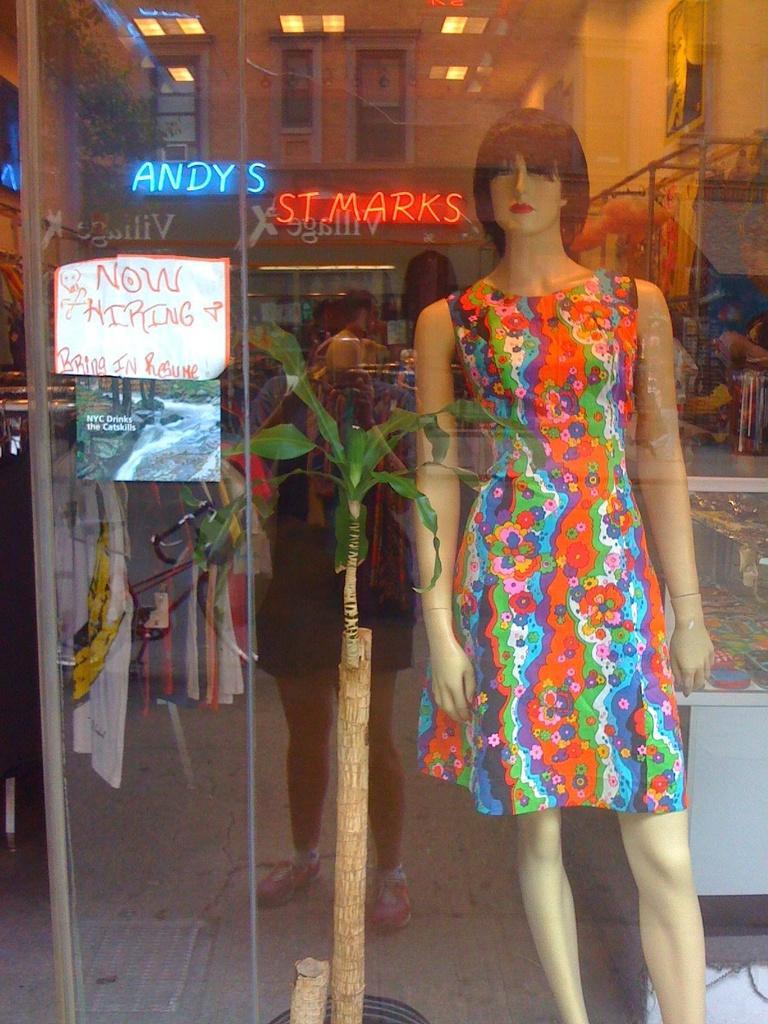Can you describe this image briefly? In this image we can see a mannequin with dress, paper with some text pasted on the surface, we can also see some clothes, some objects placed on table, poles and a photo frame on the wall. On the left side of the image we can see a television on the wall and some plants. At the top of the image we can see some lights on the roof. In the foreground we can see a reflection of a person. 